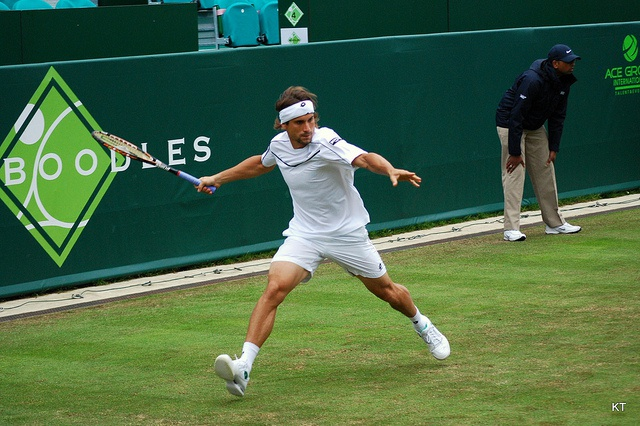Describe the objects in this image and their specific colors. I can see people in teal, lightgray, darkgray, and gray tones, people in teal, black, gray, darkgreen, and darkgray tones, chair in teal and black tones, tennis racket in teal, black, darkgray, gray, and tan tones, and chair in teal and black tones in this image. 